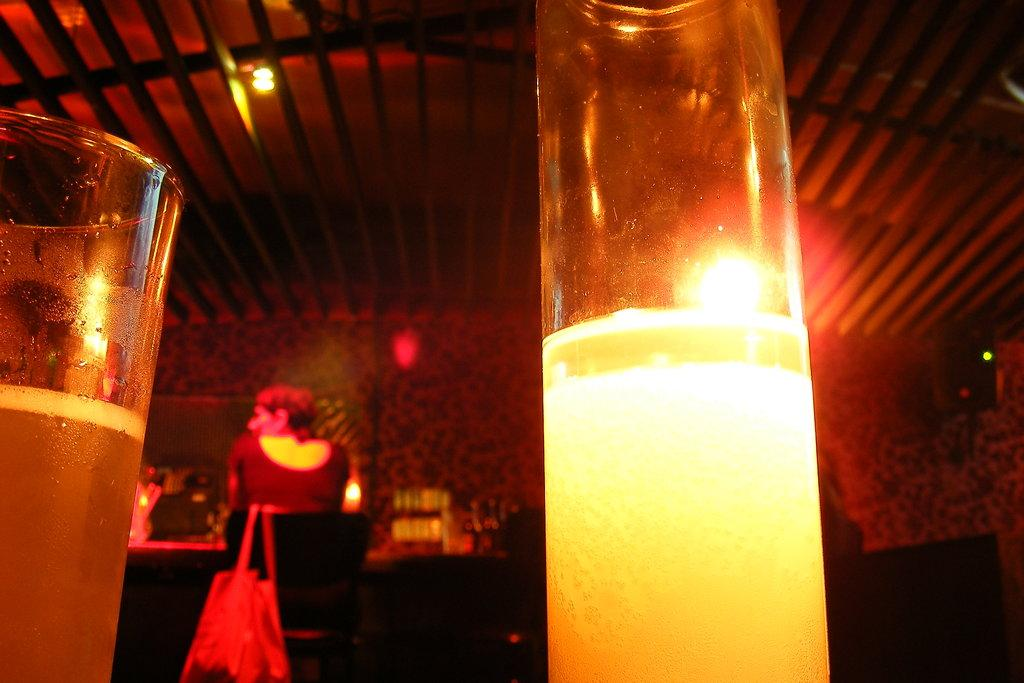What can be seen in the glasses in the image? There is liquid in the glasses in the image. What type of furniture is present in the image? There are chairs and a table in the image. What is the person sitting on in the image? The person is sitting on a chair in the image. What is the person likely to be doing in the image? The person might be sitting at the table, possibly to eat or drink. What can be seen in the background of the image? There are lights in the image. Can you describe the yard and sea visible in the image? There is no yard or sea visible in the image; it features indoor furniture and a person sitting at a table. 